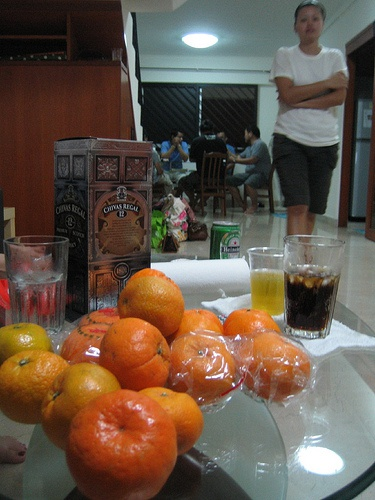Describe the objects in this image and their specific colors. I can see dining table in black, darkgray, brown, and gray tones, people in black, darkgray, gray, and maroon tones, orange in black, brown, and maroon tones, orange in black, brown, maroon, and red tones, and cup in black and gray tones in this image. 